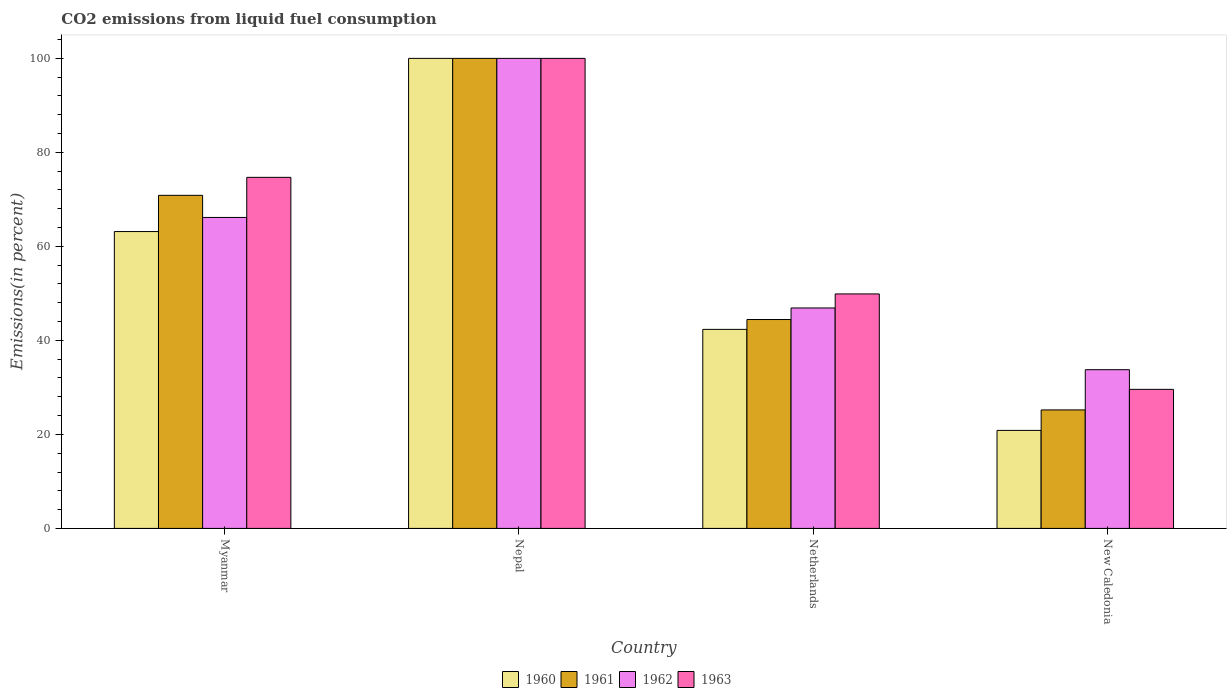How many groups of bars are there?
Keep it short and to the point. 4. Are the number of bars per tick equal to the number of legend labels?
Your answer should be compact. Yes. Are the number of bars on each tick of the X-axis equal?
Keep it short and to the point. Yes. What is the label of the 4th group of bars from the left?
Your response must be concise. New Caledonia. In how many cases, is the number of bars for a given country not equal to the number of legend labels?
Keep it short and to the point. 0. What is the total CO2 emitted in 1962 in Myanmar?
Offer a terse response. 66.16. Across all countries, what is the minimum total CO2 emitted in 1962?
Offer a very short reply. 33.77. In which country was the total CO2 emitted in 1963 maximum?
Offer a terse response. Nepal. In which country was the total CO2 emitted in 1963 minimum?
Provide a short and direct response. New Caledonia. What is the total total CO2 emitted in 1960 in the graph?
Keep it short and to the point. 226.35. What is the difference between the total CO2 emitted in 1962 in Nepal and that in Netherlands?
Offer a very short reply. 53.1. What is the difference between the total CO2 emitted in 1962 in Netherlands and the total CO2 emitted in 1960 in New Caledonia?
Your answer should be compact. 26.05. What is the average total CO2 emitted in 1962 per country?
Offer a terse response. 61.71. What is the difference between the total CO2 emitted of/in 1960 and total CO2 emitted of/in 1963 in Nepal?
Provide a short and direct response. 0. In how many countries, is the total CO2 emitted in 1960 greater than 52 %?
Your answer should be compact. 2. What is the ratio of the total CO2 emitted in 1960 in Nepal to that in Netherlands?
Give a very brief answer. 2.36. What is the difference between the highest and the second highest total CO2 emitted in 1961?
Your answer should be very brief. 29.14. What is the difference between the highest and the lowest total CO2 emitted in 1962?
Give a very brief answer. 66.23. In how many countries, is the total CO2 emitted in 1963 greater than the average total CO2 emitted in 1963 taken over all countries?
Offer a very short reply. 2. Is the sum of the total CO2 emitted in 1960 in Nepal and Netherlands greater than the maximum total CO2 emitted in 1962 across all countries?
Provide a short and direct response. Yes. Is it the case that in every country, the sum of the total CO2 emitted in 1963 and total CO2 emitted in 1962 is greater than the sum of total CO2 emitted in 1961 and total CO2 emitted in 1960?
Your response must be concise. No. What does the 1st bar from the left in Netherlands represents?
Give a very brief answer. 1960. How many bars are there?
Ensure brevity in your answer.  16. Are all the bars in the graph horizontal?
Ensure brevity in your answer.  No. What is the difference between two consecutive major ticks on the Y-axis?
Your answer should be compact. 20. Are the values on the major ticks of Y-axis written in scientific E-notation?
Provide a short and direct response. No. How many legend labels are there?
Your answer should be very brief. 4. What is the title of the graph?
Give a very brief answer. CO2 emissions from liquid fuel consumption. Does "1989" appear as one of the legend labels in the graph?
Provide a succinct answer. No. What is the label or title of the Y-axis?
Your answer should be very brief. Emissions(in percent). What is the Emissions(in percent) of 1960 in Myanmar?
Your answer should be compact. 63.16. What is the Emissions(in percent) of 1961 in Myanmar?
Your response must be concise. 70.86. What is the Emissions(in percent) in 1962 in Myanmar?
Offer a very short reply. 66.16. What is the Emissions(in percent) of 1963 in Myanmar?
Keep it short and to the point. 74.69. What is the Emissions(in percent) in 1960 in Nepal?
Offer a terse response. 100. What is the Emissions(in percent) in 1962 in Nepal?
Ensure brevity in your answer.  100. What is the Emissions(in percent) of 1960 in Netherlands?
Make the answer very short. 42.34. What is the Emissions(in percent) of 1961 in Netherlands?
Ensure brevity in your answer.  44.44. What is the Emissions(in percent) of 1962 in Netherlands?
Ensure brevity in your answer.  46.9. What is the Emissions(in percent) of 1963 in Netherlands?
Ensure brevity in your answer.  49.89. What is the Emissions(in percent) of 1960 in New Caledonia?
Give a very brief answer. 20.85. What is the Emissions(in percent) in 1961 in New Caledonia?
Offer a very short reply. 25.21. What is the Emissions(in percent) in 1962 in New Caledonia?
Provide a succinct answer. 33.77. What is the Emissions(in percent) of 1963 in New Caledonia?
Make the answer very short. 29.59. Across all countries, what is the maximum Emissions(in percent) of 1960?
Provide a short and direct response. 100. Across all countries, what is the maximum Emissions(in percent) in 1961?
Provide a short and direct response. 100. Across all countries, what is the maximum Emissions(in percent) in 1962?
Keep it short and to the point. 100. Across all countries, what is the minimum Emissions(in percent) of 1960?
Keep it short and to the point. 20.85. Across all countries, what is the minimum Emissions(in percent) of 1961?
Keep it short and to the point. 25.21. Across all countries, what is the minimum Emissions(in percent) of 1962?
Offer a very short reply. 33.77. Across all countries, what is the minimum Emissions(in percent) of 1963?
Your answer should be very brief. 29.59. What is the total Emissions(in percent) of 1960 in the graph?
Your response must be concise. 226.35. What is the total Emissions(in percent) of 1961 in the graph?
Your answer should be compact. 240.51. What is the total Emissions(in percent) of 1962 in the graph?
Make the answer very short. 246.82. What is the total Emissions(in percent) in 1963 in the graph?
Offer a very short reply. 254.16. What is the difference between the Emissions(in percent) in 1960 in Myanmar and that in Nepal?
Provide a short and direct response. -36.84. What is the difference between the Emissions(in percent) in 1961 in Myanmar and that in Nepal?
Offer a terse response. -29.14. What is the difference between the Emissions(in percent) of 1962 in Myanmar and that in Nepal?
Provide a succinct answer. -33.84. What is the difference between the Emissions(in percent) of 1963 in Myanmar and that in Nepal?
Ensure brevity in your answer.  -25.31. What is the difference between the Emissions(in percent) in 1960 in Myanmar and that in Netherlands?
Your answer should be compact. 20.81. What is the difference between the Emissions(in percent) of 1961 in Myanmar and that in Netherlands?
Offer a terse response. 26.42. What is the difference between the Emissions(in percent) in 1962 in Myanmar and that in Netherlands?
Provide a short and direct response. 19.26. What is the difference between the Emissions(in percent) of 1963 in Myanmar and that in Netherlands?
Ensure brevity in your answer.  24.8. What is the difference between the Emissions(in percent) in 1960 in Myanmar and that in New Caledonia?
Offer a terse response. 42.31. What is the difference between the Emissions(in percent) of 1961 in Myanmar and that in New Caledonia?
Keep it short and to the point. 45.66. What is the difference between the Emissions(in percent) of 1962 in Myanmar and that in New Caledonia?
Your answer should be compact. 32.39. What is the difference between the Emissions(in percent) in 1963 in Myanmar and that in New Caledonia?
Your response must be concise. 45.1. What is the difference between the Emissions(in percent) in 1960 in Nepal and that in Netherlands?
Ensure brevity in your answer.  57.66. What is the difference between the Emissions(in percent) of 1961 in Nepal and that in Netherlands?
Ensure brevity in your answer.  55.56. What is the difference between the Emissions(in percent) of 1962 in Nepal and that in Netherlands?
Offer a very short reply. 53.1. What is the difference between the Emissions(in percent) in 1963 in Nepal and that in Netherlands?
Offer a terse response. 50.11. What is the difference between the Emissions(in percent) of 1960 in Nepal and that in New Caledonia?
Your answer should be very brief. 79.15. What is the difference between the Emissions(in percent) in 1961 in Nepal and that in New Caledonia?
Keep it short and to the point. 74.79. What is the difference between the Emissions(in percent) in 1962 in Nepal and that in New Caledonia?
Keep it short and to the point. 66.23. What is the difference between the Emissions(in percent) of 1963 in Nepal and that in New Caledonia?
Give a very brief answer. 70.41. What is the difference between the Emissions(in percent) of 1960 in Netherlands and that in New Caledonia?
Offer a very short reply. 21.49. What is the difference between the Emissions(in percent) of 1961 in Netherlands and that in New Caledonia?
Provide a short and direct response. 19.23. What is the difference between the Emissions(in percent) in 1962 in Netherlands and that in New Caledonia?
Offer a terse response. 13.13. What is the difference between the Emissions(in percent) of 1963 in Netherlands and that in New Caledonia?
Make the answer very short. 20.3. What is the difference between the Emissions(in percent) in 1960 in Myanmar and the Emissions(in percent) in 1961 in Nepal?
Keep it short and to the point. -36.84. What is the difference between the Emissions(in percent) of 1960 in Myanmar and the Emissions(in percent) of 1962 in Nepal?
Your response must be concise. -36.84. What is the difference between the Emissions(in percent) in 1960 in Myanmar and the Emissions(in percent) in 1963 in Nepal?
Provide a short and direct response. -36.84. What is the difference between the Emissions(in percent) of 1961 in Myanmar and the Emissions(in percent) of 1962 in Nepal?
Offer a terse response. -29.14. What is the difference between the Emissions(in percent) in 1961 in Myanmar and the Emissions(in percent) in 1963 in Nepal?
Offer a terse response. -29.14. What is the difference between the Emissions(in percent) in 1962 in Myanmar and the Emissions(in percent) in 1963 in Nepal?
Your answer should be very brief. -33.84. What is the difference between the Emissions(in percent) in 1960 in Myanmar and the Emissions(in percent) in 1961 in Netherlands?
Provide a short and direct response. 18.72. What is the difference between the Emissions(in percent) of 1960 in Myanmar and the Emissions(in percent) of 1962 in Netherlands?
Provide a succinct answer. 16.26. What is the difference between the Emissions(in percent) of 1960 in Myanmar and the Emissions(in percent) of 1963 in Netherlands?
Keep it short and to the point. 13.27. What is the difference between the Emissions(in percent) of 1961 in Myanmar and the Emissions(in percent) of 1962 in Netherlands?
Give a very brief answer. 23.96. What is the difference between the Emissions(in percent) in 1961 in Myanmar and the Emissions(in percent) in 1963 in Netherlands?
Your answer should be very brief. 20.98. What is the difference between the Emissions(in percent) of 1962 in Myanmar and the Emissions(in percent) of 1963 in Netherlands?
Offer a terse response. 16.27. What is the difference between the Emissions(in percent) in 1960 in Myanmar and the Emissions(in percent) in 1961 in New Caledonia?
Provide a succinct answer. 37.95. What is the difference between the Emissions(in percent) of 1960 in Myanmar and the Emissions(in percent) of 1962 in New Caledonia?
Your answer should be very brief. 29.39. What is the difference between the Emissions(in percent) in 1960 in Myanmar and the Emissions(in percent) in 1963 in New Caledonia?
Provide a succinct answer. 33.57. What is the difference between the Emissions(in percent) of 1961 in Myanmar and the Emissions(in percent) of 1962 in New Caledonia?
Provide a short and direct response. 37.1. What is the difference between the Emissions(in percent) in 1961 in Myanmar and the Emissions(in percent) in 1963 in New Caledonia?
Offer a very short reply. 41.28. What is the difference between the Emissions(in percent) in 1962 in Myanmar and the Emissions(in percent) in 1963 in New Caledonia?
Provide a short and direct response. 36.57. What is the difference between the Emissions(in percent) of 1960 in Nepal and the Emissions(in percent) of 1961 in Netherlands?
Your answer should be compact. 55.56. What is the difference between the Emissions(in percent) in 1960 in Nepal and the Emissions(in percent) in 1962 in Netherlands?
Your response must be concise. 53.1. What is the difference between the Emissions(in percent) in 1960 in Nepal and the Emissions(in percent) in 1963 in Netherlands?
Provide a succinct answer. 50.11. What is the difference between the Emissions(in percent) in 1961 in Nepal and the Emissions(in percent) in 1962 in Netherlands?
Provide a succinct answer. 53.1. What is the difference between the Emissions(in percent) of 1961 in Nepal and the Emissions(in percent) of 1963 in Netherlands?
Offer a very short reply. 50.11. What is the difference between the Emissions(in percent) in 1962 in Nepal and the Emissions(in percent) in 1963 in Netherlands?
Offer a very short reply. 50.11. What is the difference between the Emissions(in percent) of 1960 in Nepal and the Emissions(in percent) of 1961 in New Caledonia?
Ensure brevity in your answer.  74.79. What is the difference between the Emissions(in percent) of 1960 in Nepal and the Emissions(in percent) of 1962 in New Caledonia?
Offer a terse response. 66.23. What is the difference between the Emissions(in percent) of 1960 in Nepal and the Emissions(in percent) of 1963 in New Caledonia?
Keep it short and to the point. 70.41. What is the difference between the Emissions(in percent) of 1961 in Nepal and the Emissions(in percent) of 1962 in New Caledonia?
Offer a very short reply. 66.23. What is the difference between the Emissions(in percent) of 1961 in Nepal and the Emissions(in percent) of 1963 in New Caledonia?
Offer a terse response. 70.41. What is the difference between the Emissions(in percent) in 1962 in Nepal and the Emissions(in percent) in 1963 in New Caledonia?
Your answer should be compact. 70.41. What is the difference between the Emissions(in percent) in 1960 in Netherlands and the Emissions(in percent) in 1961 in New Caledonia?
Your answer should be compact. 17.14. What is the difference between the Emissions(in percent) of 1960 in Netherlands and the Emissions(in percent) of 1962 in New Caledonia?
Your response must be concise. 8.58. What is the difference between the Emissions(in percent) in 1960 in Netherlands and the Emissions(in percent) in 1963 in New Caledonia?
Provide a succinct answer. 12.76. What is the difference between the Emissions(in percent) of 1961 in Netherlands and the Emissions(in percent) of 1962 in New Caledonia?
Your response must be concise. 10.67. What is the difference between the Emissions(in percent) in 1961 in Netherlands and the Emissions(in percent) in 1963 in New Caledonia?
Make the answer very short. 14.85. What is the difference between the Emissions(in percent) of 1962 in Netherlands and the Emissions(in percent) of 1963 in New Caledonia?
Provide a succinct answer. 17.31. What is the average Emissions(in percent) in 1960 per country?
Give a very brief answer. 56.59. What is the average Emissions(in percent) of 1961 per country?
Offer a very short reply. 60.13. What is the average Emissions(in percent) of 1962 per country?
Give a very brief answer. 61.71. What is the average Emissions(in percent) of 1963 per country?
Make the answer very short. 63.54. What is the difference between the Emissions(in percent) of 1960 and Emissions(in percent) of 1961 in Myanmar?
Ensure brevity in your answer.  -7.7. What is the difference between the Emissions(in percent) in 1960 and Emissions(in percent) in 1962 in Myanmar?
Provide a succinct answer. -3. What is the difference between the Emissions(in percent) of 1960 and Emissions(in percent) of 1963 in Myanmar?
Provide a short and direct response. -11.53. What is the difference between the Emissions(in percent) in 1961 and Emissions(in percent) in 1962 in Myanmar?
Provide a short and direct response. 4.71. What is the difference between the Emissions(in percent) in 1961 and Emissions(in percent) in 1963 in Myanmar?
Keep it short and to the point. -3.82. What is the difference between the Emissions(in percent) of 1962 and Emissions(in percent) of 1963 in Myanmar?
Offer a very short reply. -8.53. What is the difference between the Emissions(in percent) in 1960 and Emissions(in percent) in 1961 in Netherlands?
Offer a terse response. -2.1. What is the difference between the Emissions(in percent) of 1960 and Emissions(in percent) of 1962 in Netherlands?
Offer a very short reply. -4.55. What is the difference between the Emissions(in percent) of 1960 and Emissions(in percent) of 1963 in Netherlands?
Give a very brief answer. -7.54. What is the difference between the Emissions(in percent) in 1961 and Emissions(in percent) in 1962 in Netherlands?
Your answer should be very brief. -2.46. What is the difference between the Emissions(in percent) in 1961 and Emissions(in percent) in 1963 in Netherlands?
Offer a very short reply. -5.45. What is the difference between the Emissions(in percent) in 1962 and Emissions(in percent) in 1963 in Netherlands?
Give a very brief answer. -2.99. What is the difference between the Emissions(in percent) in 1960 and Emissions(in percent) in 1961 in New Caledonia?
Keep it short and to the point. -4.36. What is the difference between the Emissions(in percent) of 1960 and Emissions(in percent) of 1962 in New Caledonia?
Offer a terse response. -12.92. What is the difference between the Emissions(in percent) in 1960 and Emissions(in percent) in 1963 in New Caledonia?
Offer a very short reply. -8.73. What is the difference between the Emissions(in percent) of 1961 and Emissions(in percent) of 1962 in New Caledonia?
Your answer should be very brief. -8.56. What is the difference between the Emissions(in percent) in 1961 and Emissions(in percent) in 1963 in New Caledonia?
Make the answer very short. -4.38. What is the difference between the Emissions(in percent) in 1962 and Emissions(in percent) in 1963 in New Caledonia?
Provide a short and direct response. 4.18. What is the ratio of the Emissions(in percent) in 1960 in Myanmar to that in Nepal?
Offer a very short reply. 0.63. What is the ratio of the Emissions(in percent) of 1961 in Myanmar to that in Nepal?
Give a very brief answer. 0.71. What is the ratio of the Emissions(in percent) of 1962 in Myanmar to that in Nepal?
Your answer should be very brief. 0.66. What is the ratio of the Emissions(in percent) of 1963 in Myanmar to that in Nepal?
Provide a succinct answer. 0.75. What is the ratio of the Emissions(in percent) of 1960 in Myanmar to that in Netherlands?
Offer a terse response. 1.49. What is the ratio of the Emissions(in percent) in 1961 in Myanmar to that in Netherlands?
Your answer should be compact. 1.59. What is the ratio of the Emissions(in percent) in 1962 in Myanmar to that in Netherlands?
Offer a very short reply. 1.41. What is the ratio of the Emissions(in percent) of 1963 in Myanmar to that in Netherlands?
Offer a very short reply. 1.5. What is the ratio of the Emissions(in percent) of 1960 in Myanmar to that in New Caledonia?
Provide a succinct answer. 3.03. What is the ratio of the Emissions(in percent) of 1961 in Myanmar to that in New Caledonia?
Offer a terse response. 2.81. What is the ratio of the Emissions(in percent) in 1962 in Myanmar to that in New Caledonia?
Make the answer very short. 1.96. What is the ratio of the Emissions(in percent) of 1963 in Myanmar to that in New Caledonia?
Your answer should be very brief. 2.52. What is the ratio of the Emissions(in percent) of 1960 in Nepal to that in Netherlands?
Make the answer very short. 2.36. What is the ratio of the Emissions(in percent) of 1961 in Nepal to that in Netherlands?
Offer a terse response. 2.25. What is the ratio of the Emissions(in percent) in 1962 in Nepal to that in Netherlands?
Provide a succinct answer. 2.13. What is the ratio of the Emissions(in percent) in 1963 in Nepal to that in Netherlands?
Provide a succinct answer. 2. What is the ratio of the Emissions(in percent) of 1960 in Nepal to that in New Caledonia?
Provide a succinct answer. 4.8. What is the ratio of the Emissions(in percent) of 1961 in Nepal to that in New Caledonia?
Provide a succinct answer. 3.97. What is the ratio of the Emissions(in percent) in 1962 in Nepal to that in New Caledonia?
Make the answer very short. 2.96. What is the ratio of the Emissions(in percent) of 1963 in Nepal to that in New Caledonia?
Make the answer very short. 3.38. What is the ratio of the Emissions(in percent) in 1960 in Netherlands to that in New Caledonia?
Ensure brevity in your answer.  2.03. What is the ratio of the Emissions(in percent) of 1961 in Netherlands to that in New Caledonia?
Ensure brevity in your answer.  1.76. What is the ratio of the Emissions(in percent) of 1962 in Netherlands to that in New Caledonia?
Your answer should be very brief. 1.39. What is the ratio of the Emissions(in percent) in 1963 in Netherlands to that in New Caledonia?
Your response must be concise. 1.69. What is the difference between the highest and the second highest Emissions(in percent) in 1960?
Your answer should be compact. 36.84. What is the difference between the highest and the second highest Emissions(in percent) in 1961?
Provide a short and direct response. 29.14. What is the difference between the highest and the second highest Emissions(in percent) of 1962?
Provide a succinct answer. 33.84. What is the difference between the highest and the second highest Emissions(in percent) in 1963?
Ensure brevity in your answer.  25.31. What is the difference between the highest and the lowest Emissions(in percent) in 1960?
Provide a succinct answer. 79.15. What is the difference between the highest and the lowest Emissions(in percent) in 1961?
Offer a very short reply. 74.79. What is the difference between the highest and the lowest Emissions(in percent) of 1962?
Your response must be concise. 66.23. What is the difference between the highest and the lowest Emissions(in percent) of 1963?
Keep it short and to the point. 70.41. 